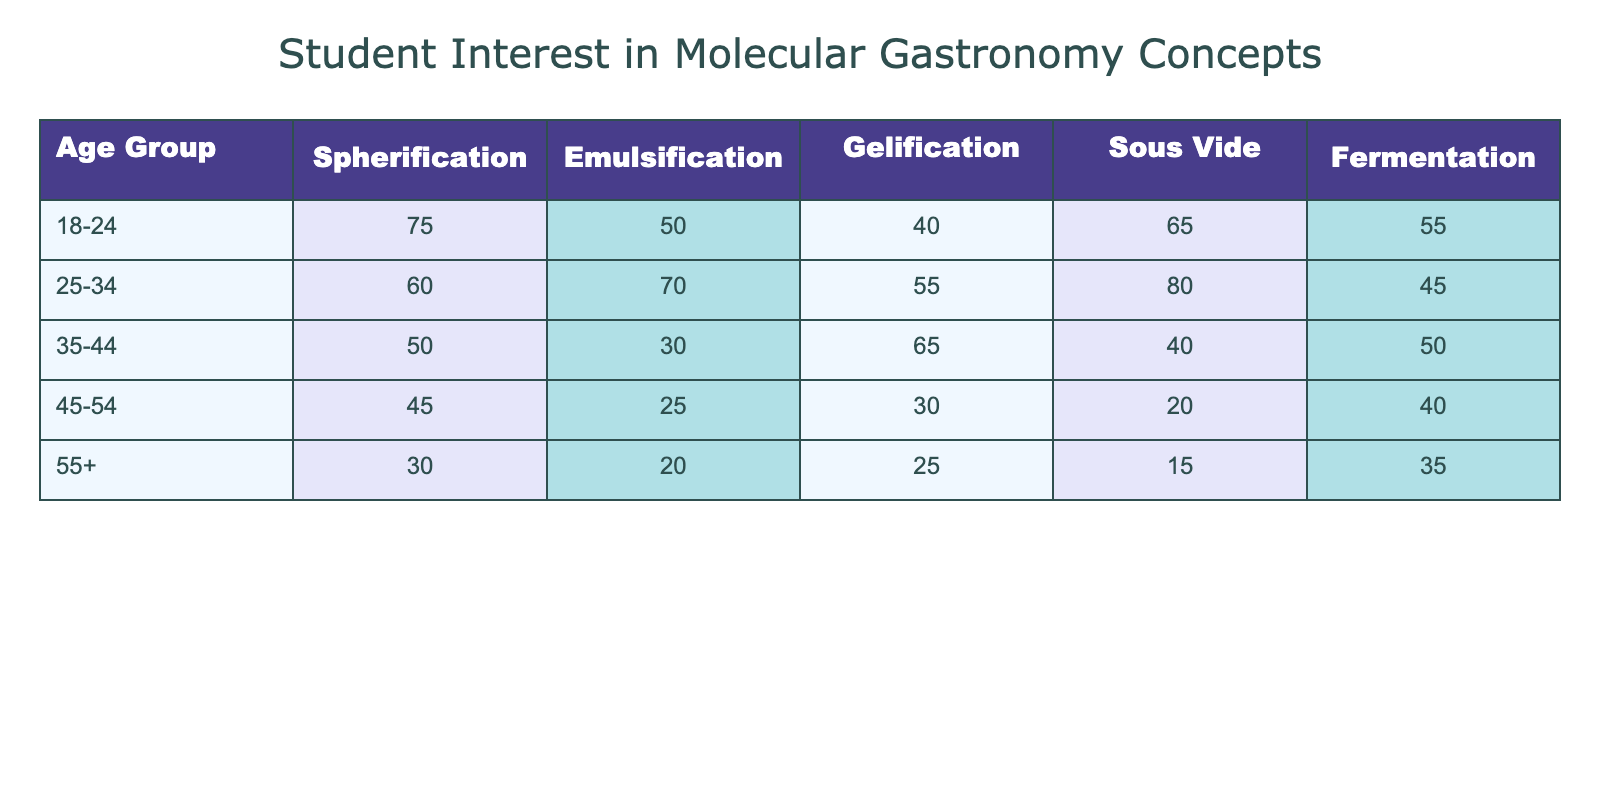What age group has the highest interest in Spherification? By examining the column for Spherification, we can see that the highest value is 75, which belongs to the age group 18-24.
Answer: 18-24 What is the interest level in Sous Vide for the age group 45-54? Looking at the row for the age group 45-54, the corresponding value under Sous Vide is 20.
Answer: 20 Which molecular gastronomy concept received the lowest score from the 35-44 age group? By checking the row for the 35-44 age group, we see the values for the various concepts: Spherification (50), Emulsification (30), Gelification (65), Sous Vide (40), Fermentation (50). The lowest score is 30 for Emulsification.
Answer: Emulsification What is the average interest level in Fermentation for all age groups? The interest levels in Fermentation are: 55, 45, 50, 40, 35. To find the average, we sum these values: 55 + 45 + 50 + 40 + 35 = 225. Then, we divide the total by the number of age groups (5): 225/5 = 45.
Answer: 45 Is the interest level in Gelification higher for the age group 25-34 than for 45-54? Checking the values, the interest in Gelification for 25-34 is 55, and for 45-54 is 30. Thus, 55 is greater than 30, so the statement is true.
Answer: Yes Which age group shows the most interest in Emulsification compared to others? By reviewing the values for Emulsification across all age groups, we observe: 50, 70, 30, 25, 20. The highest value of 70 belongs to the age group 25-34, making this group the most interested.
Answer: 25-34 What is the difference in interest levels between Spherification and Sous Vide for the age group 55+? For the age group 55+, the interest level in Spherification is 30 and in Sous Vide is 15. To find the difference, we subtract: 30 - 15 = 15.
Answer: 15 How many of the age groups have a higher interest in Fermentation than 50? Examining the interest levels in Fermentation: 55 (18-24), 45 (25-34), 50 (35-44), 40 (45-54), 35 (55+). Only the age group 18-24 has a score higher than 50.
Answer: 1 What is the total interest level in Gelification across all age groups? The Gelification scores for each age group are 40 (18-24), 55 (25-34), 65 (35-44), 30 (45-54), and 25 (55+). The total is calculated by summing these values: 40 + 55 + 65 + 30 + 25 = 215.
Answer: 215 